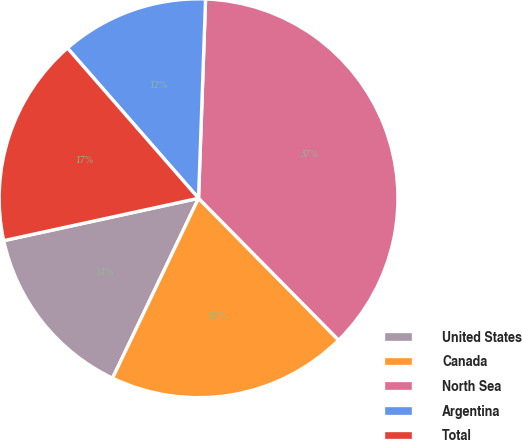<chart> <loc_0><loc_0><loc_500><loc_500><pie_chart><fcel>United States<fcel>Canada<fcel>North Sea<fcel>Argentina<fcel>Total<nl><fcel>14.49%<fcel>19.5%<fcel>37.04%<fcel>11.98%<fcel>16.99%<nl></chart> 